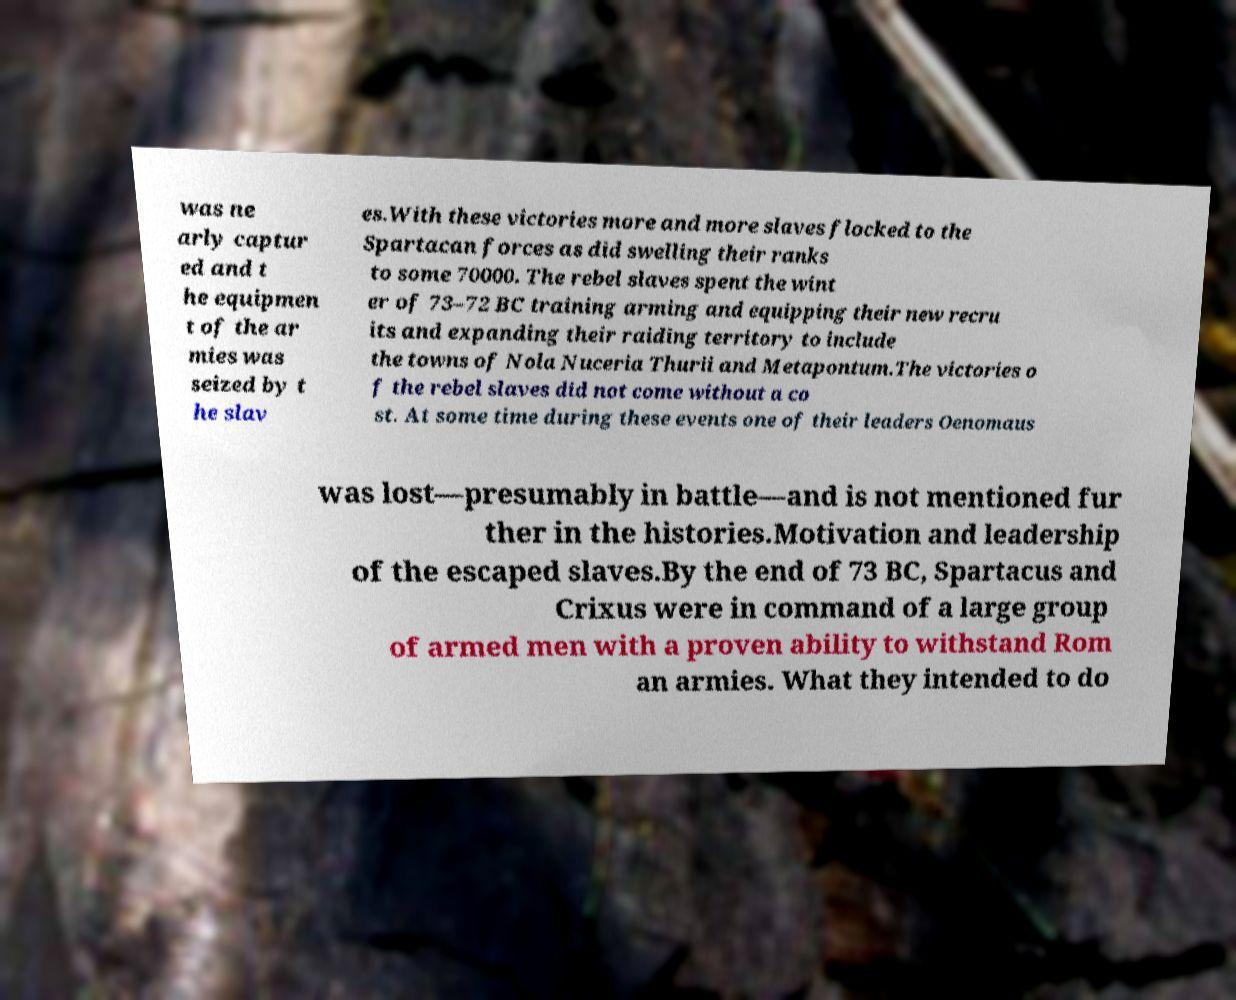Could you extract and type out the text from this image? was ne arly captur ed and t he equipmen t of the ar mies was seized by t he slav es.With these victories more and more slaves flocked to the Spartacan forces as did swelling their ranks to some 70000. The rebel slaves spent the wint er of 73–72 BC training arming and equipping their new recru its and expanding their raiding territory to include the towns of Nola Nuceria Thurii and Metapontum.The victories o f the rebel slaves did not come without a co st. At some time during these events one of their leaders Oenomaus was lost—presumably in battle—and is not mentioned fur ther in the histories.Motivation and leadership of the escaped slaves.By the end of 73 BC, Spartacus and Crixus were in command of a large group of armed men with a proven ability to withstand Rom an armies. What they intended to do 